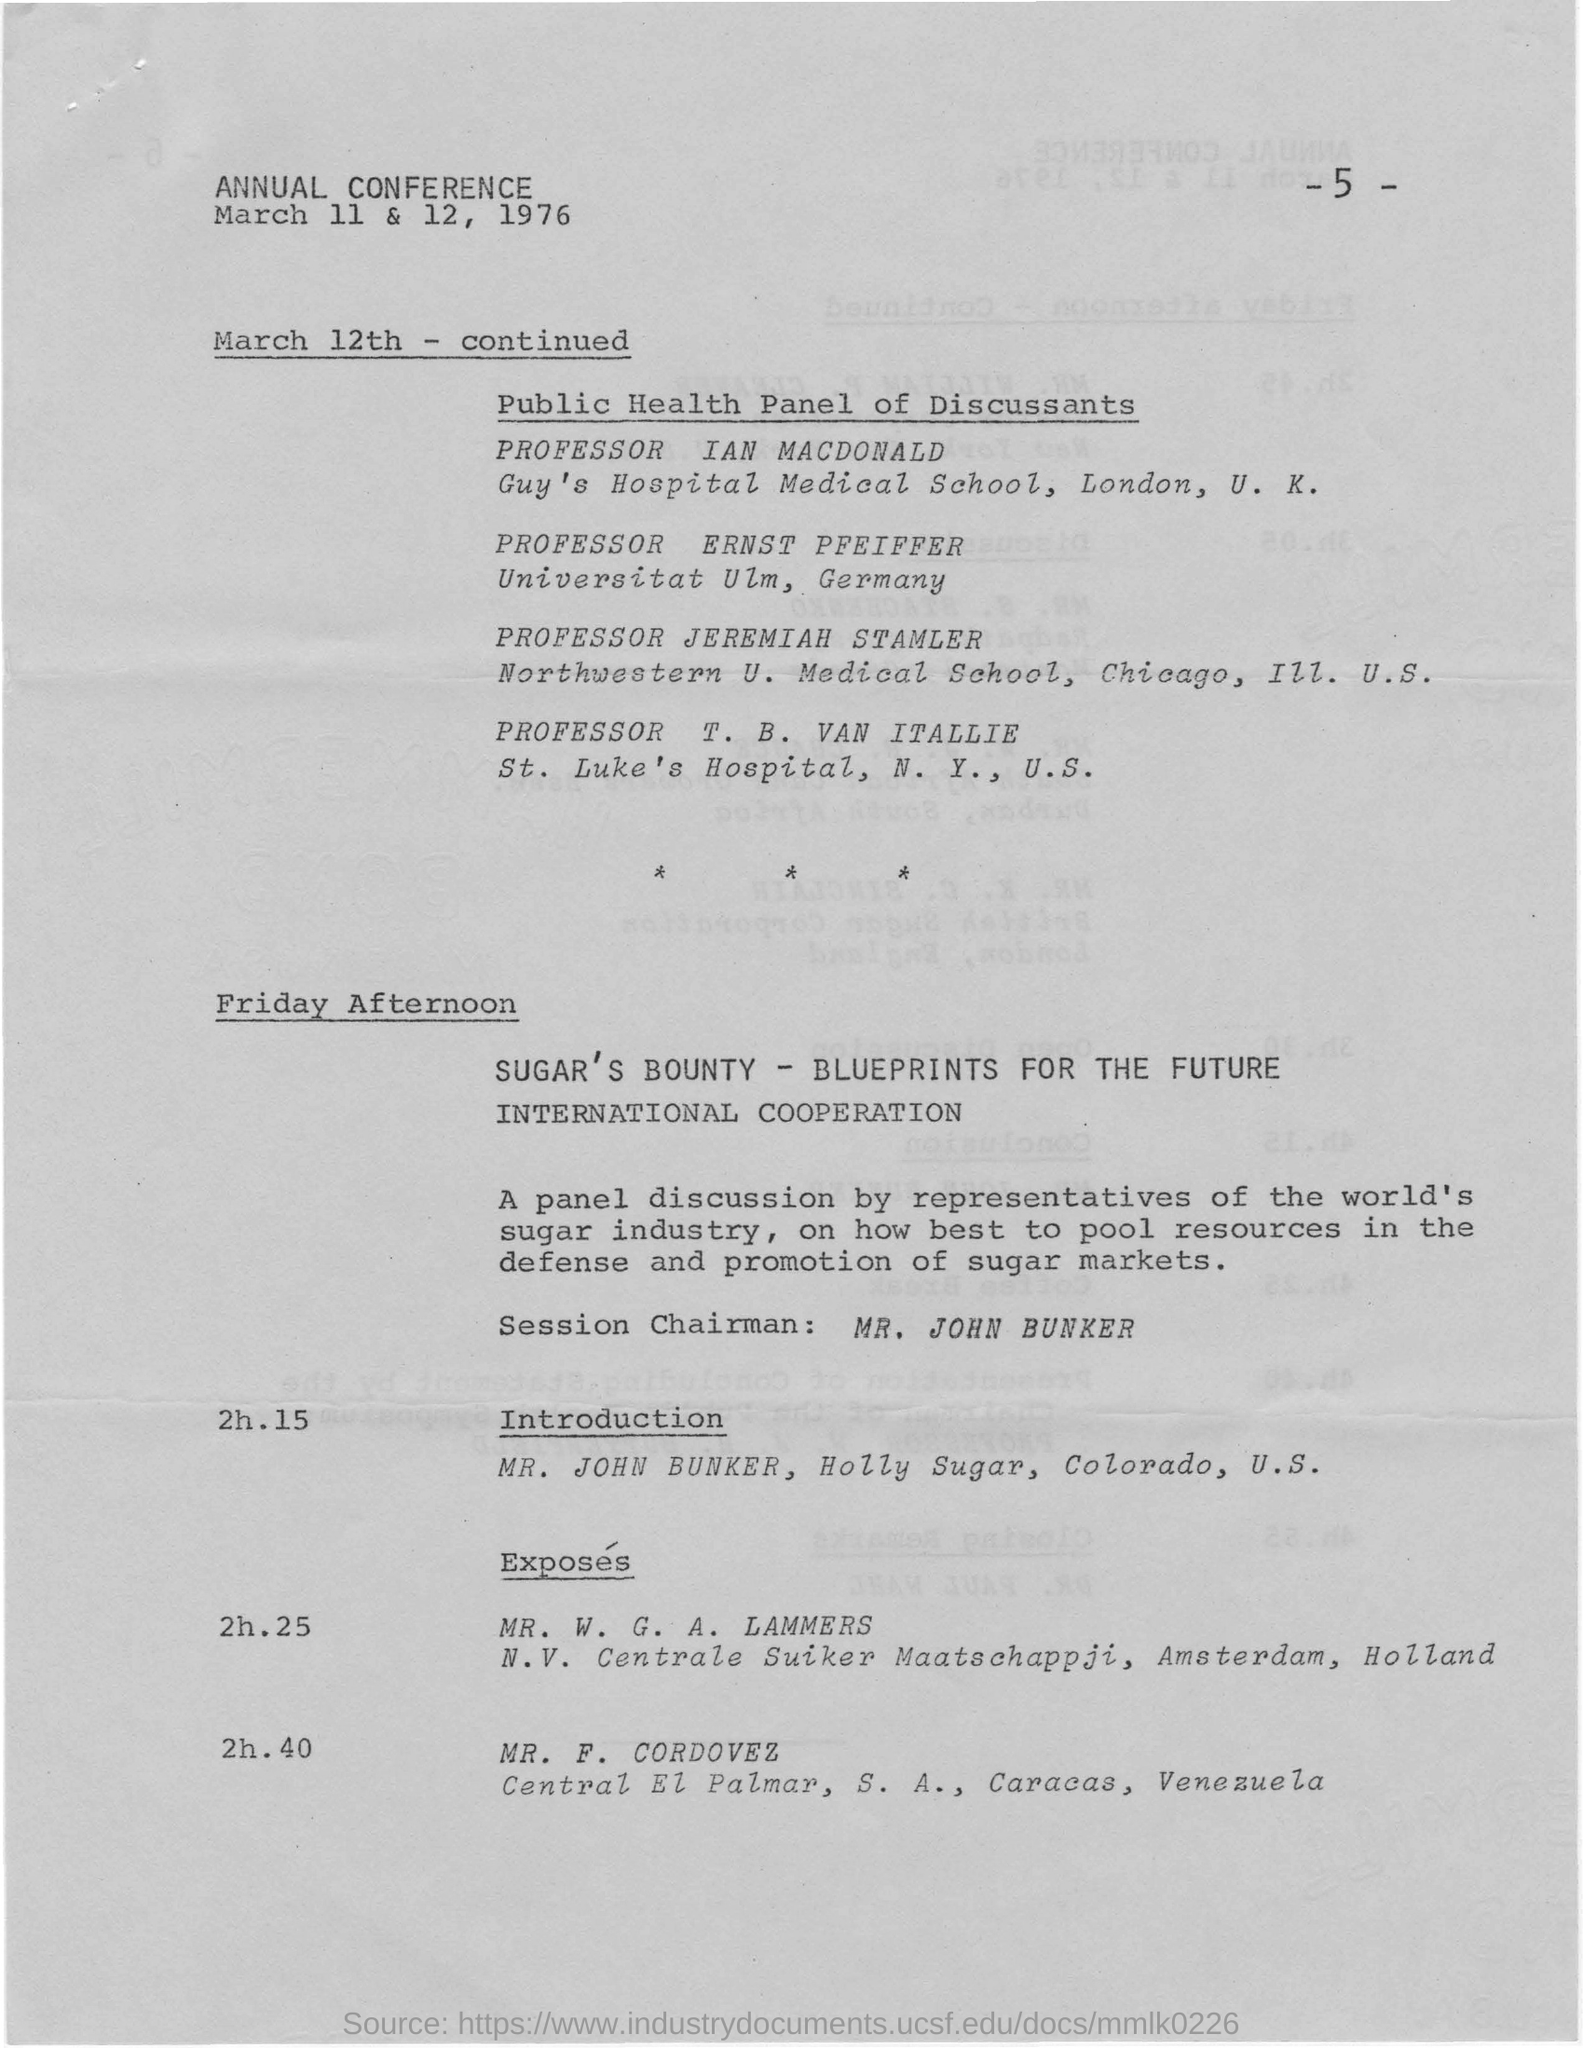Give some essential details in this illustration. The session chairman for Friday afternoon is Mr. John Bunker. MR. JOHN BUNKER is the session chairman for the panel discussion. The agenda at 2:15 on Friday afternoon includes an introduction. The conference was held in 1976. The exposure will start at what time? 